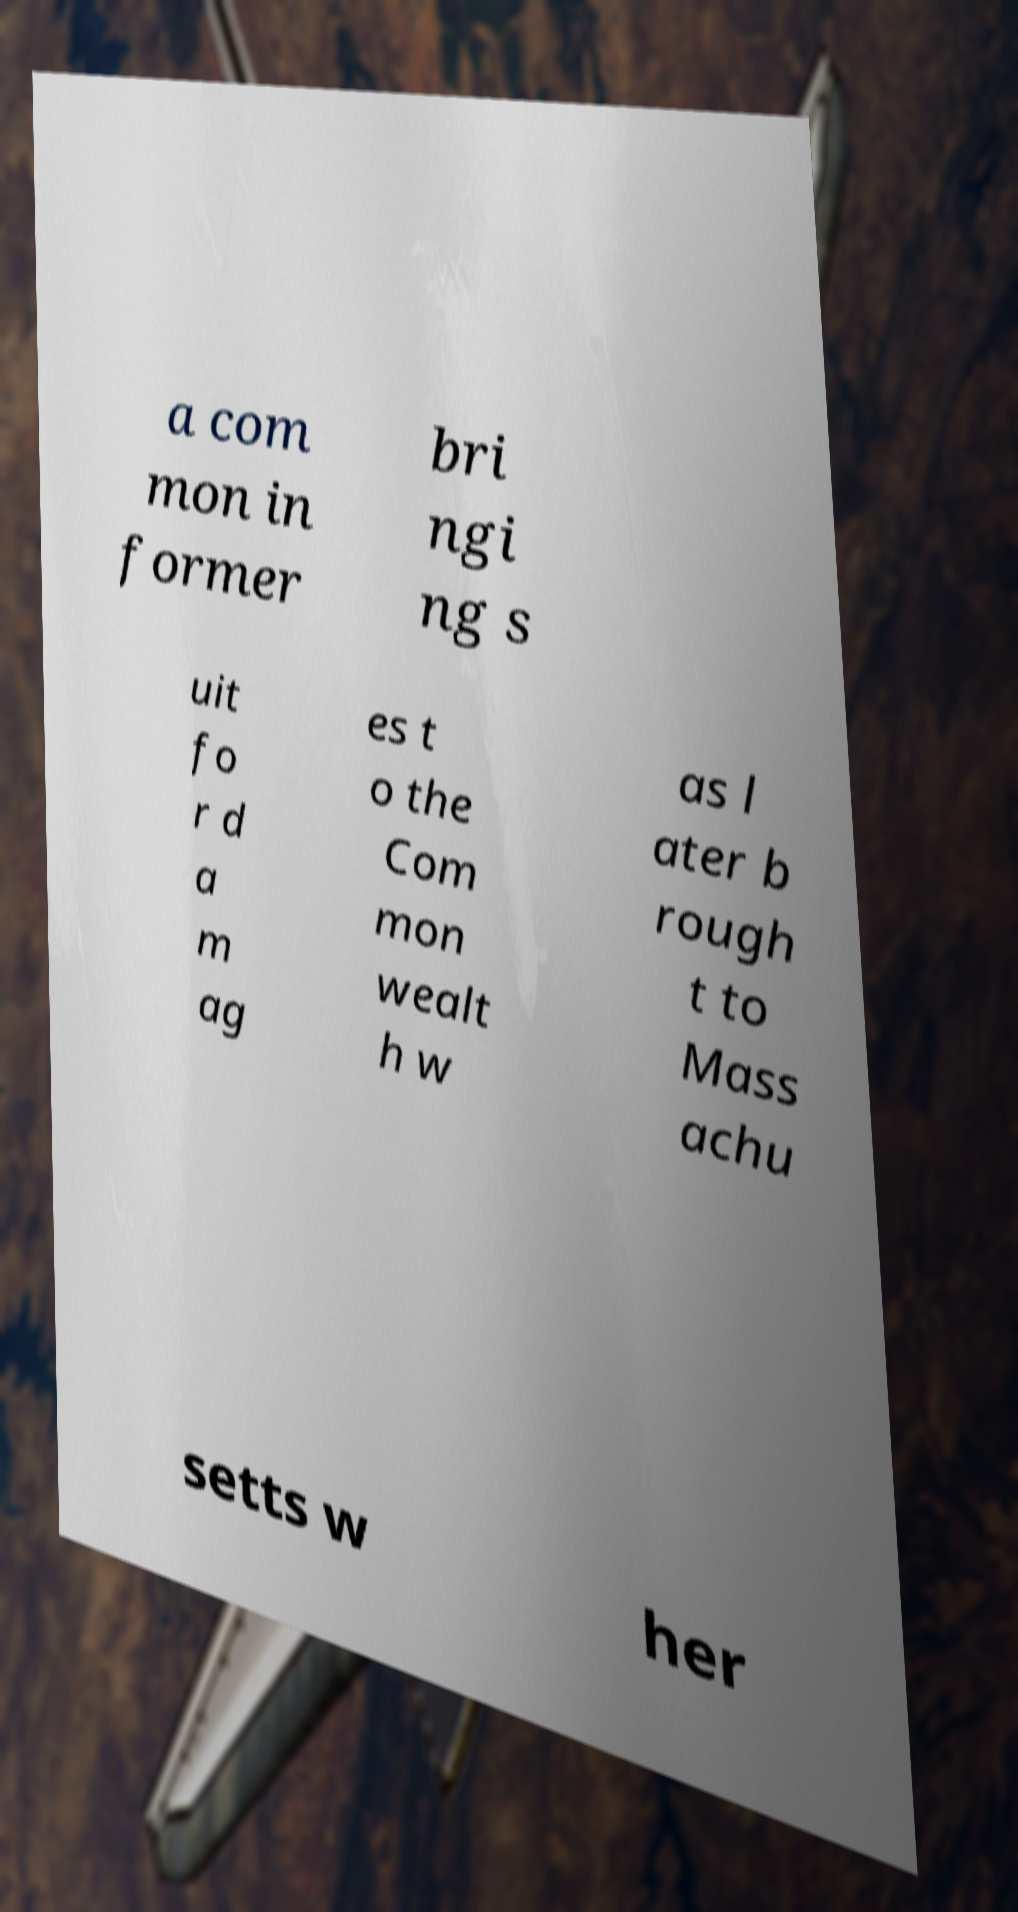What messages or text are displayed in this image? I need them in a readable, typed format. a com mon in former bri ngi ng s uit fo r d a m ag es t o the Com mon wealt h w as l ater b rough t to Mass achu setts w her 